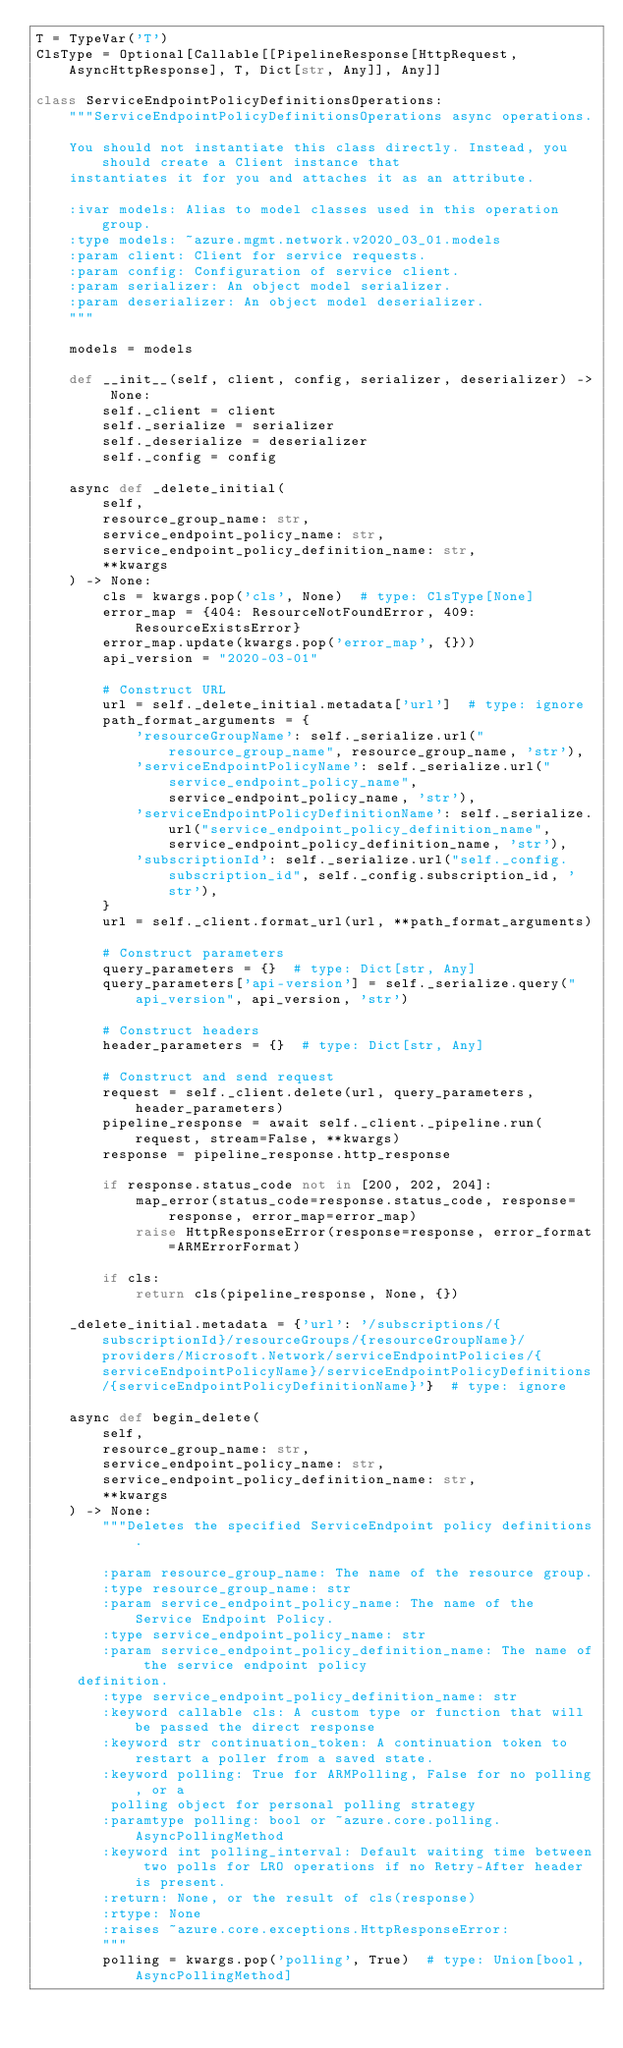<code> <loc_0><loc_0><loc_500><loc_500><_Python_>T = TypeVar('T')
ClsType = Optional[Callable[[PipelineResponse[HttpRequest, AsyncHttpResponse], T, Dict[str, Any]], Any]]

class ServiceEndpointPolicyDefinitionsOperations:
    """ServiceEndpointPolicyDefinitionsOperations async operations.

    You should not instantiate this class directly. Instead, you should create a Client instance that
    instantiates it for you and attaches it as an attribute.

    :ivar models: Alias to model classes used in this operation group.
    :type models: ~azure.mgmt.network.v2020_03_01.models
    :param client: Client for service requests.
    :param config: Configuration of service client.
    :param serializer: An object model serializer.
    :param deserializer: An object model deserializer.
    """

    models = models

    def __init__(self, client, config, serializer, deserializer) -> None:
        self._client = client
        self._serialize = serializer
        self._deserialize = deserializer
        self._config = config

    async def _delete_initial(
        self,
        resource_group_name: str,
        service_endpoint_policy_name: str,
        service_endpoint_policy_definition_name: str,
        **kwargs
    ) -> None:
        cls = kwargs.pop('cls', None)  # type: ClsType[None]
        error_map = {404: ResourceNotFoundError, 409: ResourceExistsError}
        error_map.update(kwargs.pop('error_map', {}))
        api_version = "2020-03-01"

        # Construct URL
        url = self._delete_initial.metadata['url']  # type: ignore
        path_format_arguments = {
            'resourceGroupName': self._serialize.url("resource_group_name", resource_group_name, 'str'),
            'serviceEndpointPolicyName': self._serialize.url("service_endpoint_policy_name", service_endpoint_policy_name, 'str'),
            'serviceEndpointPolicyDefinitionName': self._serialize.url("service_endpoint_policy_definition_name", service_endpoint_policy_definition_name, 'str'),
            'subscriptionId': self._serialize.url("self._config.subscription_id", self._config.subscription_id, 'str'),
        }
        url = self._client.format_url(url, **path_format_arguments)

        # Construct parameters
        query_parameters = {}  # type: Dict[str, Any]
        query_parameters['api-version'] = self._serialize.query("api_version", api_version, 'str')

        # Construct headers
        header_parameters = {}  # type: Dict[str, Any]

        # Construct and send request
        request = self._client.delete(url, query_parameters, header_parameters)
        pipeline_response = await self._client._pipeline.run(request, stream=False, **kwargs)
        response = pipeline_response.http_response

        if response.status_code not in [200, 202, 204]:
            map_error(status_code=response.status_code, response=response, error_map=error_map)
            raise HttpResponseError(response=response, error_format=ARMErrorFormat)

        if cls:
            return cls(pipeline_response, None, {})

    _delete_initial.metadata = {'url': '/subscriptions/{subscriptionId}/resourceGroups/{resourceGroupName}/providers/Microsoft.Network/serviceEndpointPolicies/{serviceEndpointPolicyName}/serviceEndpointPolicyDefinitions/{serviceEndpointPolicyDefinitionName}'}  # type: ignore

    async def begin_delete(
        self,
        resource_group_name: str,
        service_endpoint_policy_name: str,
        service_endpoint_policy_definition_name: str,
        **kwargs
    ) -> None:
        """Deletes the specified ServiceEndpoint policy definitions.

        :param resource_group_name: The name of the resource group.
        :type resource_group_name: str
        :param service_endpoint_policy_name: The name of the Service Endpoint Policy.
        :type service_endpoint_policy_name: str
        :param service_endpoint_policy_definition_name: The name of the service endpoint policy
     definition.
        :type service_endpoint_policy_definition_name: str
        :keyword callable cls: A custom type or function that will be passed the direct response
        :keyword str continuation_token: A continuation token to restart a poller from a saved state.
        :keyword polling: True for ARMPolling, False for no polling, or a
         polling object for personal polling strategy
        :paramtype polling: bool or ~azure.core.polling.AsyncPollingMethod
        :keyword int polling_interval: Default waiting time between two polls for LRO operations if no Retry-After header is present.
        :return: None, or the result of cls(response)
        :rtype: None
        :raises ~azure.core.exceptions.HttpResponseError:
        """
        polling = kwargs.pop('polling', True)  # type: Union[bool, AsyncPollingMethod]</code> 